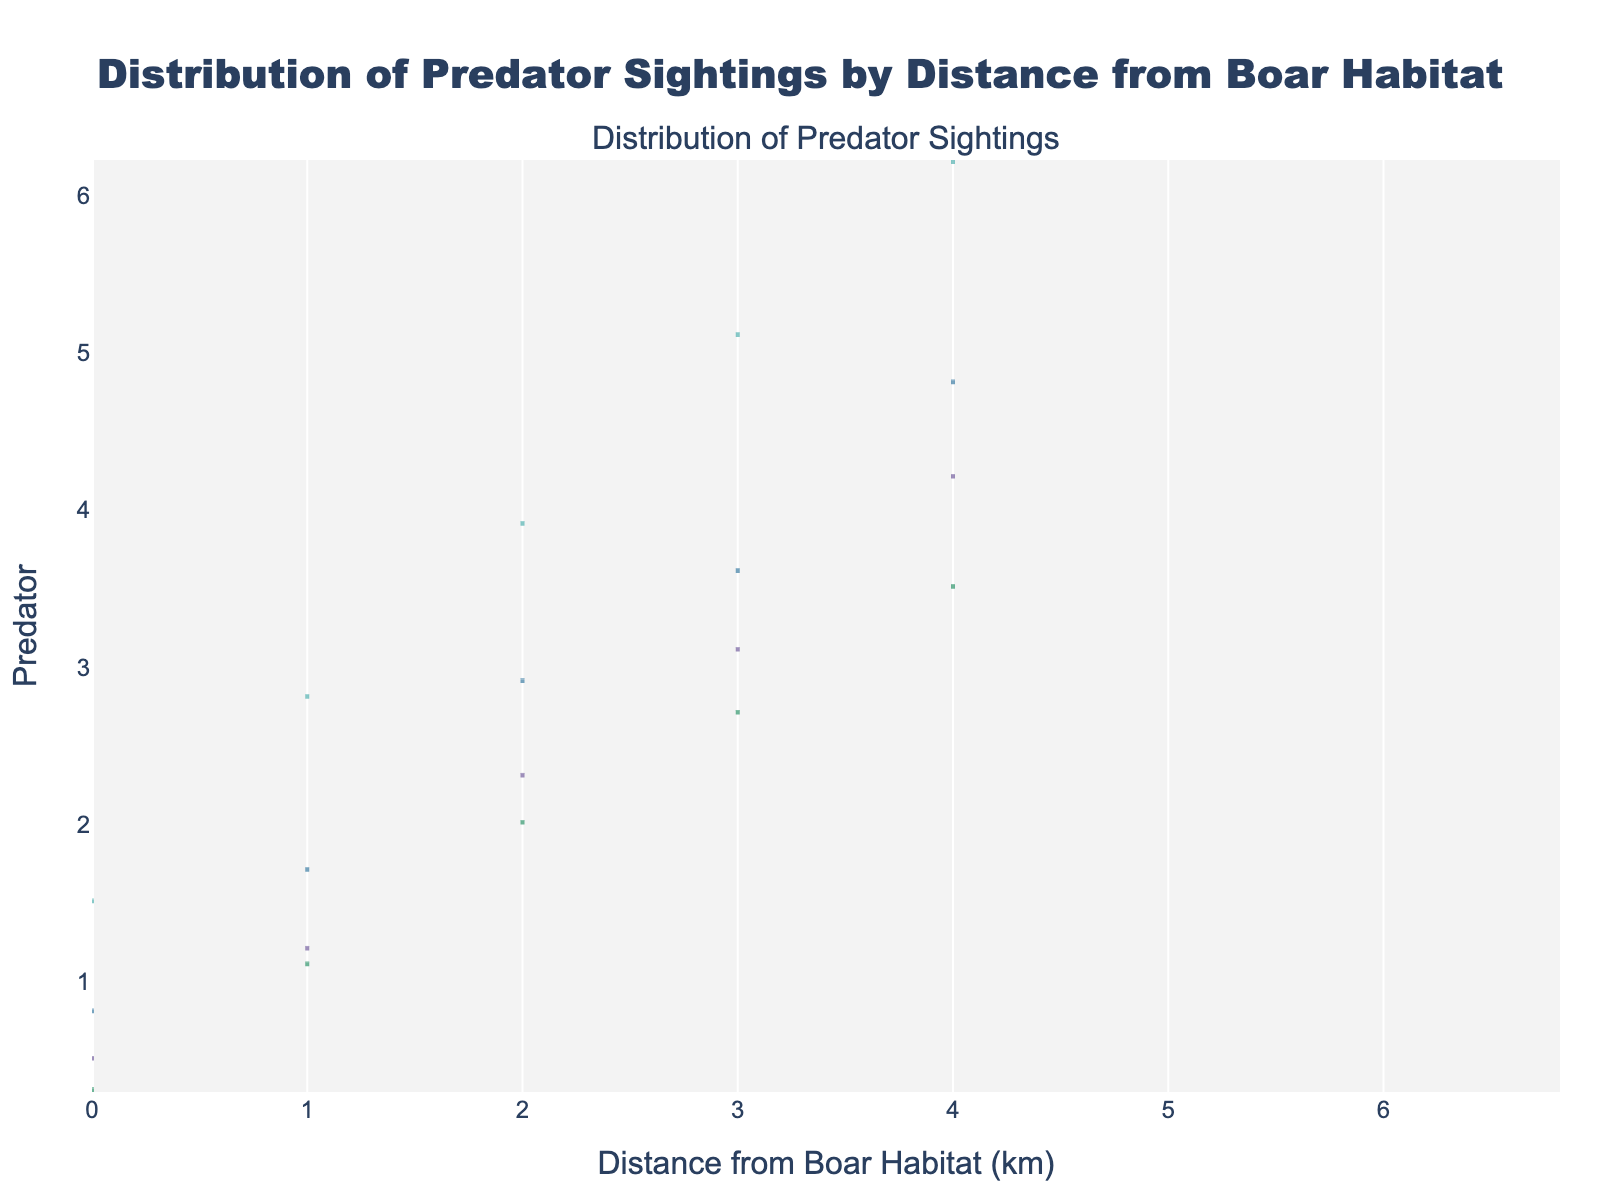what does the title of the plot indicate? The title "Distribution of Predator Sightings by Distance from Boar Habitat" indicates that the plot shows how frequently different predators are sighted at various distances from a boar habitat.
Answer: It indicates the distribution of predator sightings by distance from boar habitat Which predator is sighted closest to the boar habitat? By observing the positions of the density plots, the Fox is sighted at the closest distance from the boar habitat, as its minimum distance is very low (0.3 km).
Answer: Fox How many different predators are included in the plot? By counting the number of unique names on the density plots or within the legend, it is evident that there are four different predators: Wolf, Lynx, Bear, and Fox.
Answer: Four What is the maximum distance a Bear has been sighted from the boar habitat? By looking at the right edge of the Bear's density plot, the maximum distance a Bear has been sighted from the boar habitat is 6.2 km.
Answer: 6.2 km Which predator has the most sightings at a distance of around 3 km? By comparing the intensity around the 3 km mark for each predator's density plot, the Wolf appears to have the most sightings around that distance, as its density plot has higher values near 3 km.
Answer: Wolf What is the median distance of sighting for the Lynx? The median line in the density plot for Lynx marks the median distance, which is approximately at the 2.9 km mark.
Answer: 2.9 km How does the spread of Wolf sightings compare to that of Fox sightings? The density plot for Wolf spans from 0.5 km to about 4.2 km, while Fox sightings spread from around 0.3 km to 3.5 km. Wolf has a slightly wider spread in its sightings compared to Fox.
Answer: Wolf has a wider spread Which predator has the lowest variability in sighting distances? By observing the compactness of the density plots, the Fox's plot is the most compact, indicating it has the lowest variability in sighting distances.
Answer: Fox Between Wolf and Bear, which predator is more commonly sighted at greater distances from the habitat? By examining the right tails of the density plots, the Bear is more commonly sighted at greater distances, extending up to 6.2 km, compared to the Wolf, which extends only to about 4.2 km.
Answer: Bear 